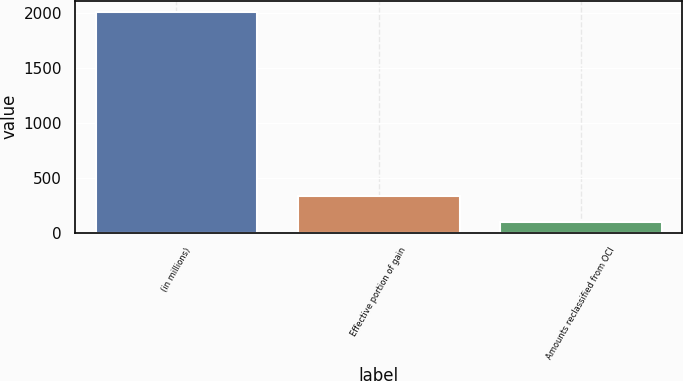Convert chart. <chart><loc_0><loc_0><loc_500><loc_500><bar_chart><fcel>(in millions)<fcel>Effective portion of gain<fcel>Amounts reclassified from OCI<nl><fcel>2014<fcel>334<fcel>99<nl></chart> 